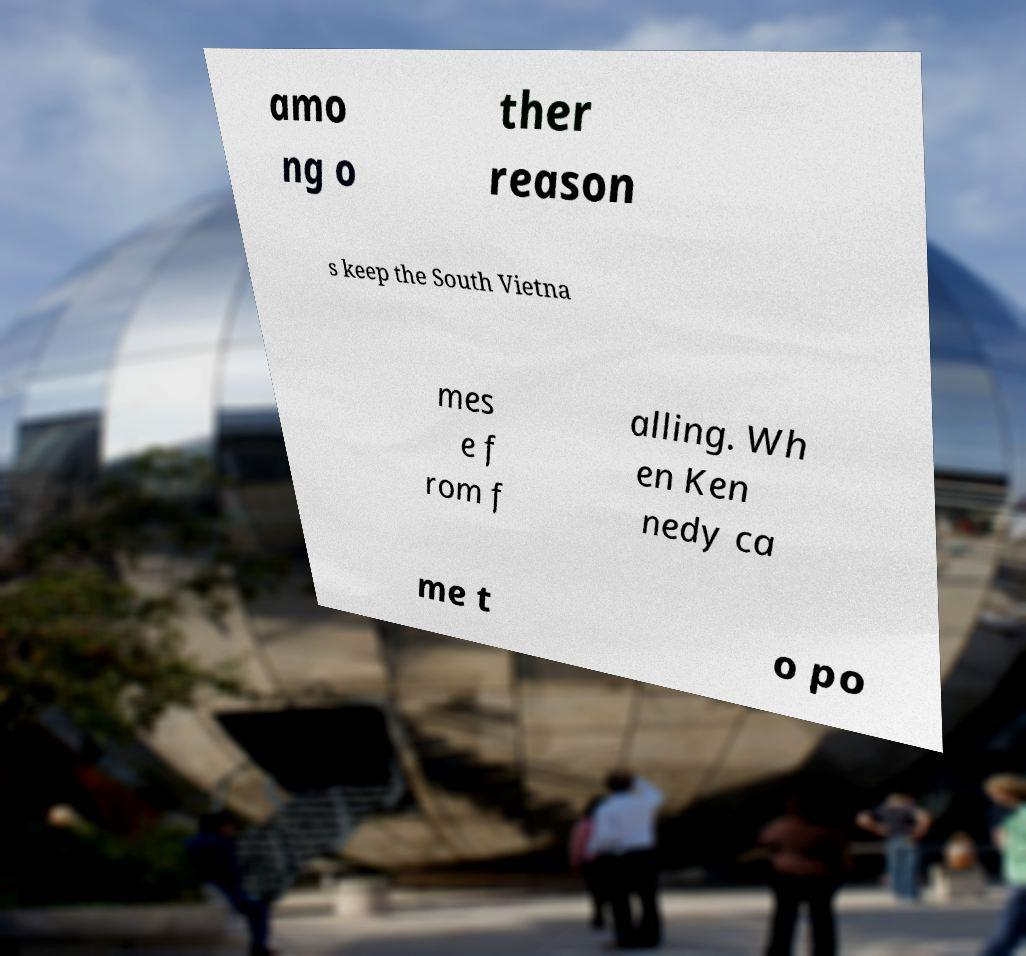For documentation purposes, I need the text within this image transcribed. Could you provide that? amo ng o ther reason s keep the South Vietna mes e f rom f alling. Wh en Ken nedy ca me t o po 